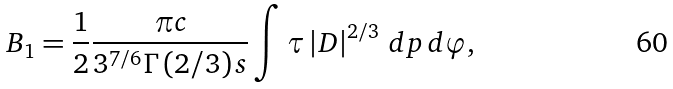<formula> <loc_0><loc_0><loc_500><loc_500>B _ { 1 } = \frac { 1 } { 2 } \frac { \pi c } { 3 ^ { 7 / 6 } \Gamma \left ( 2 / 3 \right ) s } \int \tau \left | D \right | ^ { 2 / 3 } \, d p \, d \varphi ,</formula> 